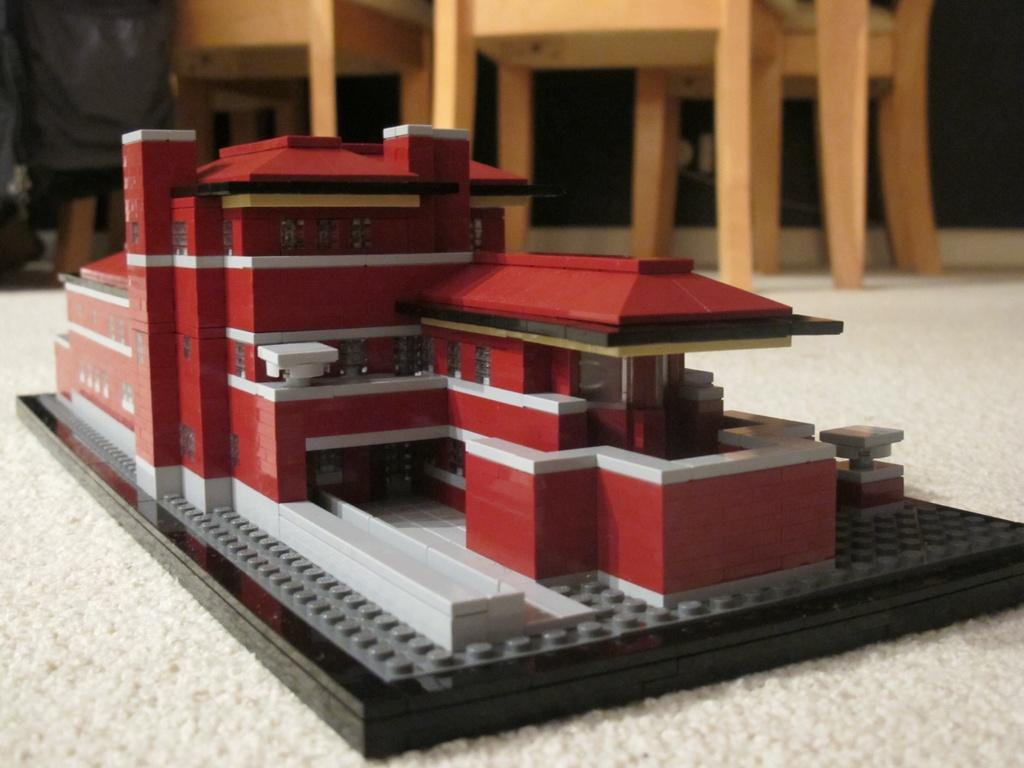What is depicted in the image? There is an architectural drawing of a building in the image. Where is the drawing placed? The drawing is on a mat. What can be seen in the background of the image? There are chairs in the background of the image. What type of paper is the jewel made of in the image? There is no mention of a jewel in the image; it features an architectural drawing of a building on a mat with chairs in the background. 